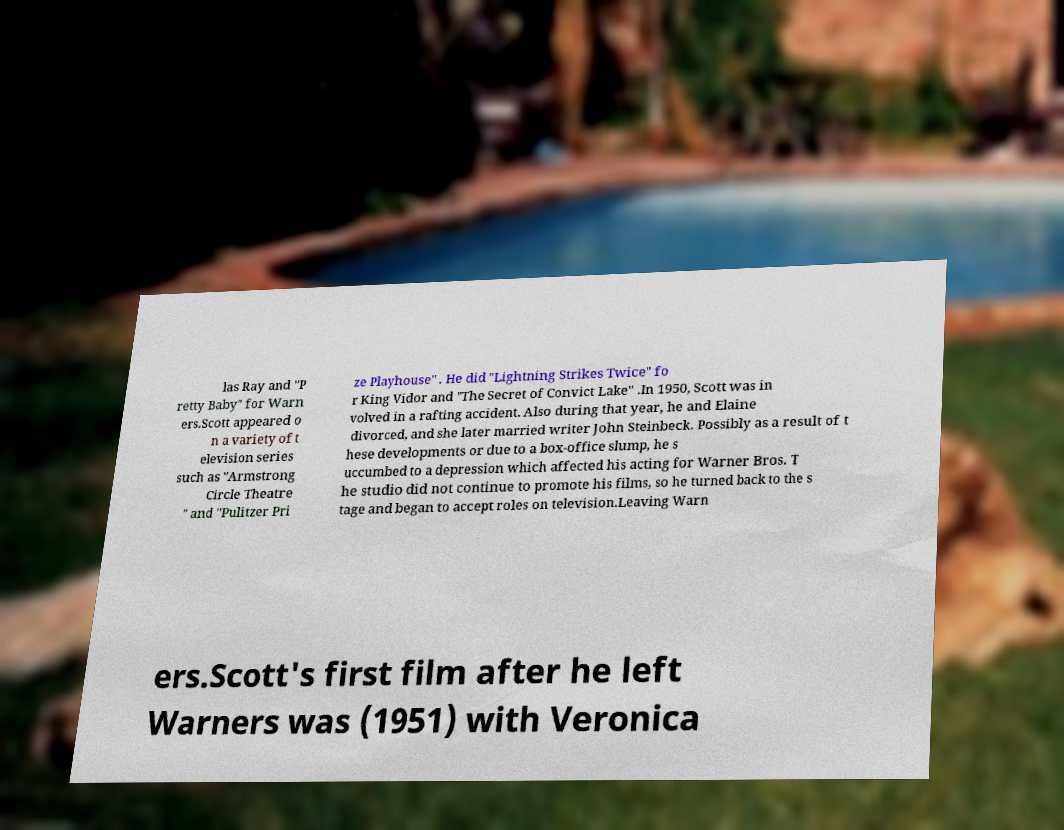Can you read and provide the text displayed in the image?This photo seems to have some interesting text. Can you extract and type it out for me? las Ray and "P retty Baby" for Warn ers.Scott appeared o n a variety of t elevision series such as "Armstrong Circle Theatre " and "Pulitzer Pri ze Playhouse" . He did "Lightning Strikes Twice" fo r King Vidor and "The Secret of Convict Lake" .In 1950, Scott was in volved in a rafting accident. Also during that year, he and Elaine divorced, and she later married writer John Steinbeck. Possibly as a result of t hese developments or due to a box-office slump, he s uccumbed to a depression which affected his acting for Warner Bros. T he studio did not continue to promote his films, so he turned back to the s tage and began to accept roles on television.Leaving Warn ers.Scott's first film after he left Warners was (1951) with Veronica 